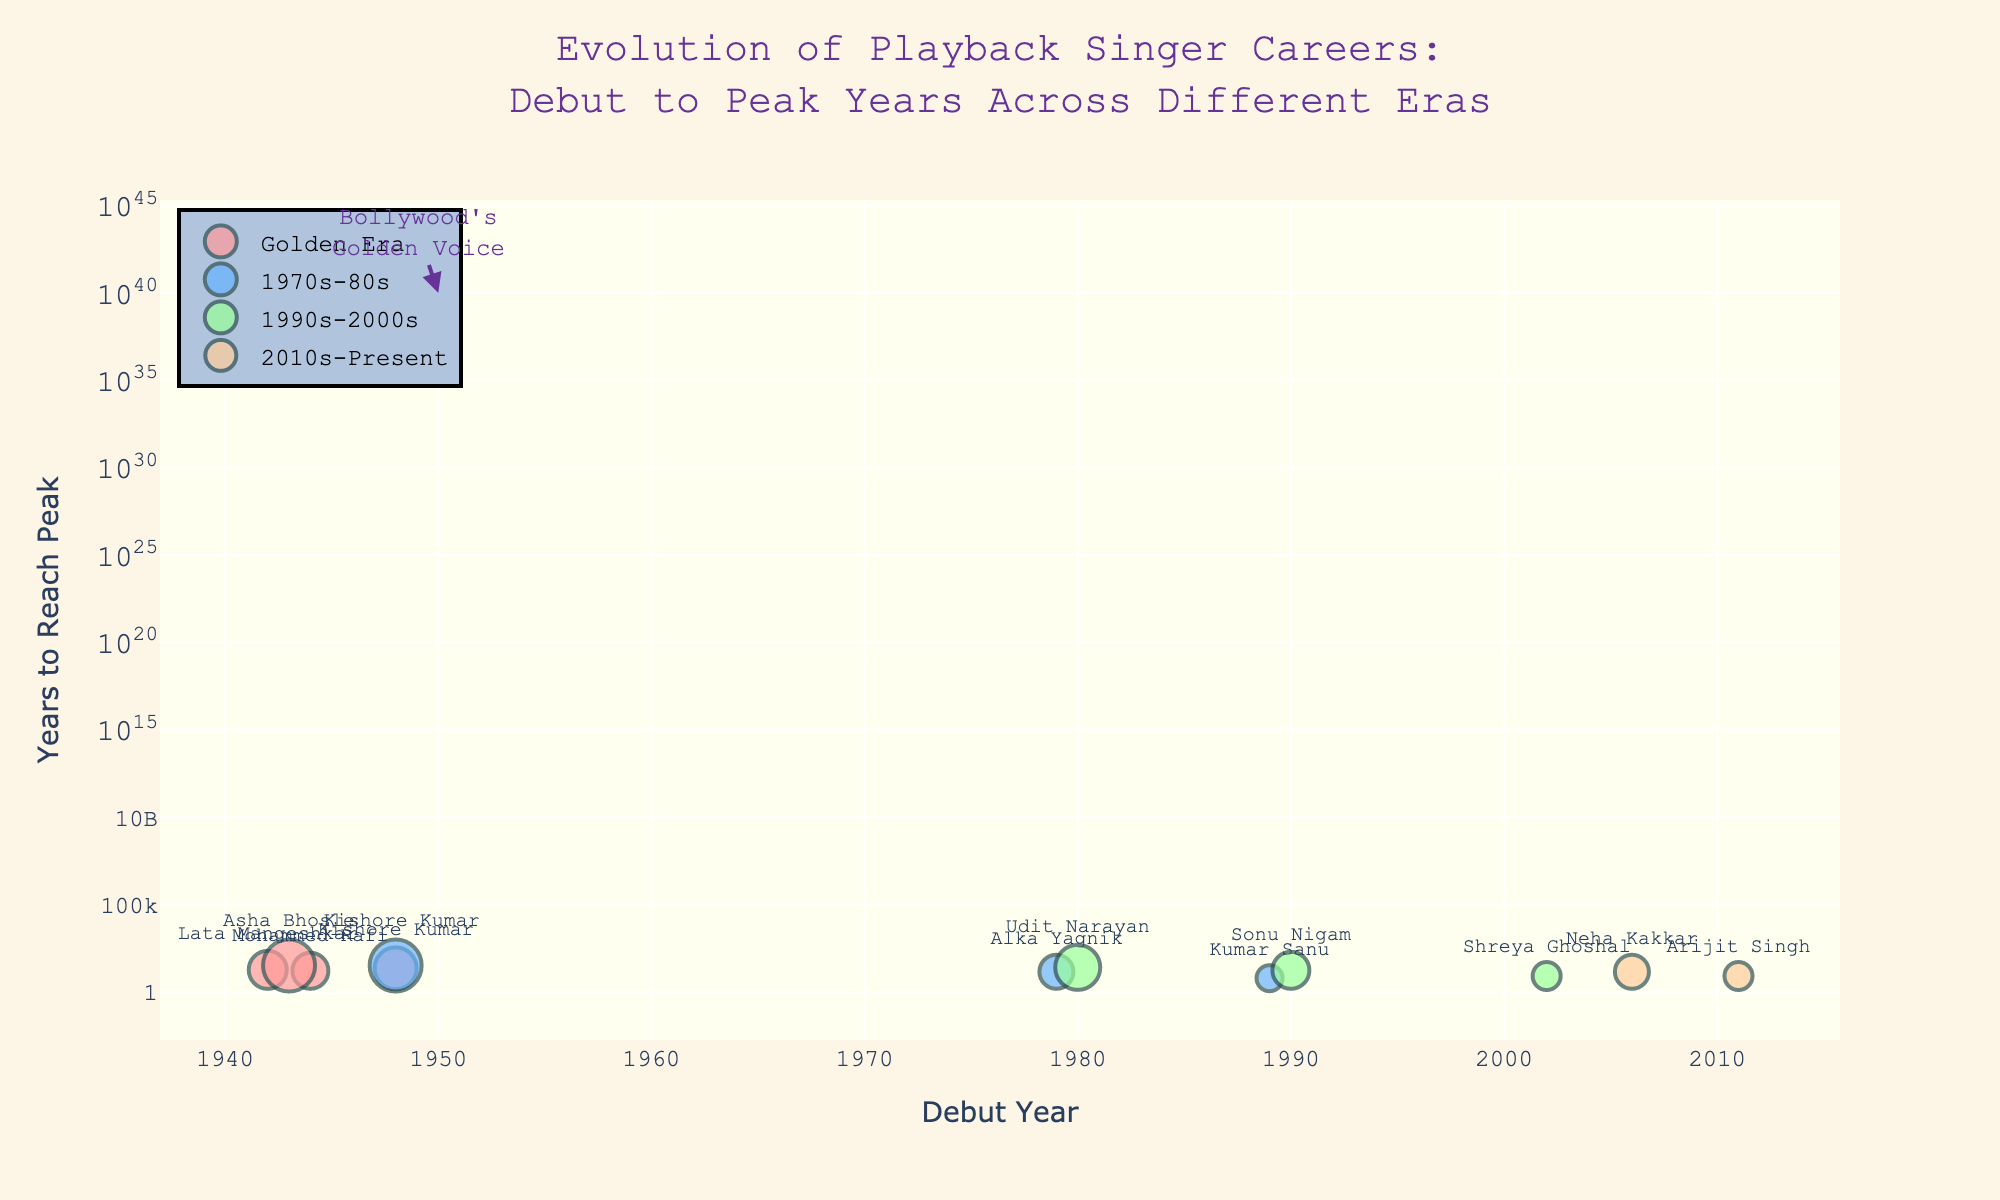What is the title of the plot? The title is found at the top of the figure in a larger and bolder font. The full title reads, "Evolution of Playback Singer Careers: Debut to Peak Years Across Different Eras."
Answer: Evolution of Playback Singer Careers: Debut to Peak Years Across Different Eras Which era shows singers who took the longest time to reach their peak careers? Look at the y-axis values for each era. The era with the highest y-axis values indicates the longest time to reach peak careers.
Answer: Golden Era Which singer made their debut in 1979 and how long did it take them to reach their peak? Locate the debut year 1979 on the x-axis and identify the corresponding data point. The singer's name is labeled as "Alka Yagnik" with the y-axis value indicating the years to peak.
Answer: Alka Yagnik, 14 years Who reached their peak career fastest among the singers who debuted in the 1940s? Focus on singers from the 1940s and compare their "Years Since Debut" values on the y-axis. The smallest value indicates the fastest to peak.
Answer: Mohammed Rafi (16 years) Compare the average time it took for singers from the Golden Era and 1990s-2000s to reach their peak. Calculate the average "Years Since Debut" for singers in each era by summing the y-axis values and dividing by the number of singers in each era.
Answer: Golden Era: (60-42 + 60-44 + 70-48 + 75-43)/4 = 20 years;  1990s-2000s: (2005-80 + 2007-90 + 2010-02)/3 = 20 years. Average time: Golden Era = 20 years, 1990s-2000s = 18 years Which era has the greatest variability in the time to reach peak careers among singers? By visually assessing each era's spread on the y-axis, the era with the most varied y-axis values indicates greater variability.
Answer: 1970s-80s Who among the singers who debuted in 2006 reached their peak career last? Identify the debut year 2006 on the x-axis and compare y-axis values for corresponding data points. The higher the value, the later the peak.
Answer: Neha Kakkar What is the time range in years for singers from 2010s-Present to reach their peak career? Identify the minimum and maximum y-axis values within the "2010s-Present" era and calculate the difference.
Answer: 8-14 years Which era had its peak years concentrated around the 1960s? Look for which era's y-axis values collectively fall around the 1960s mark on the graph.
Answer: Golden Era 